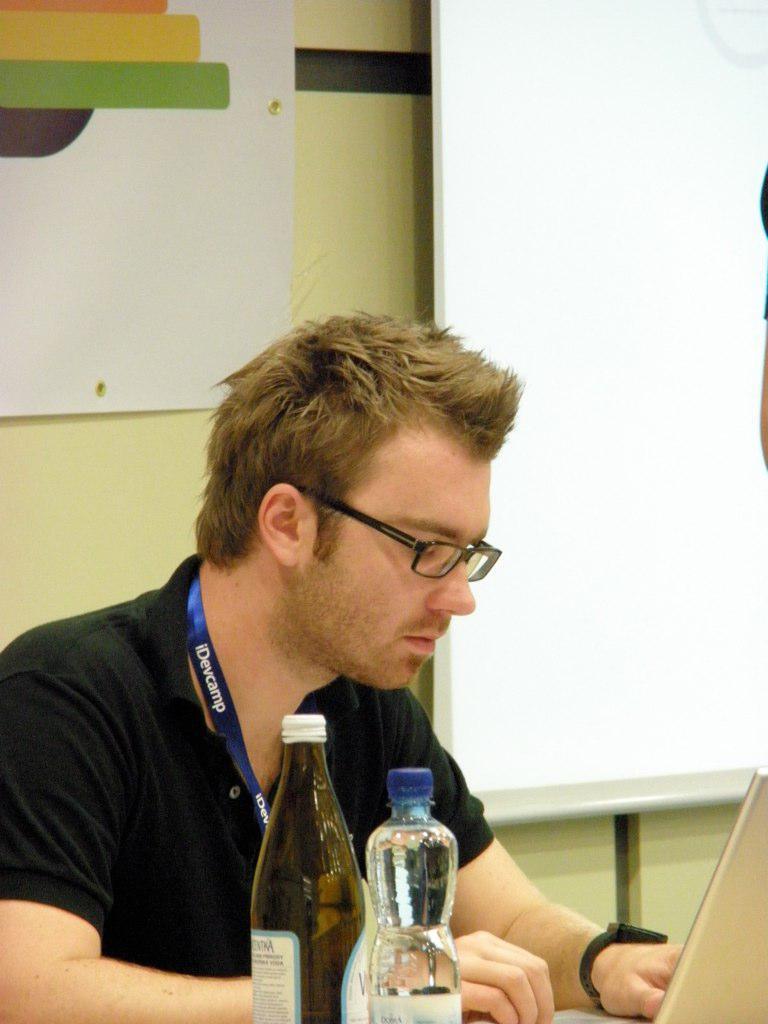In one or two sentences, can you explain what this image depicts? In this image i can see man sitting and using a laptop,there are two laptops in front of the man at the back ground i can see a board and a wall. 